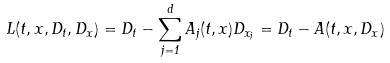<formula> <loc_0><loc_0><loc_500><loc_500>L ( t , x , D _ { t } , D _ { x } ) = D _ { t } - \sum _ { j = 1 } ^ { d } A _ { j } ( t , x ) D _ { x _ { j } } = D _ { t } - A ( t , x , D _ { x } )</formula> 